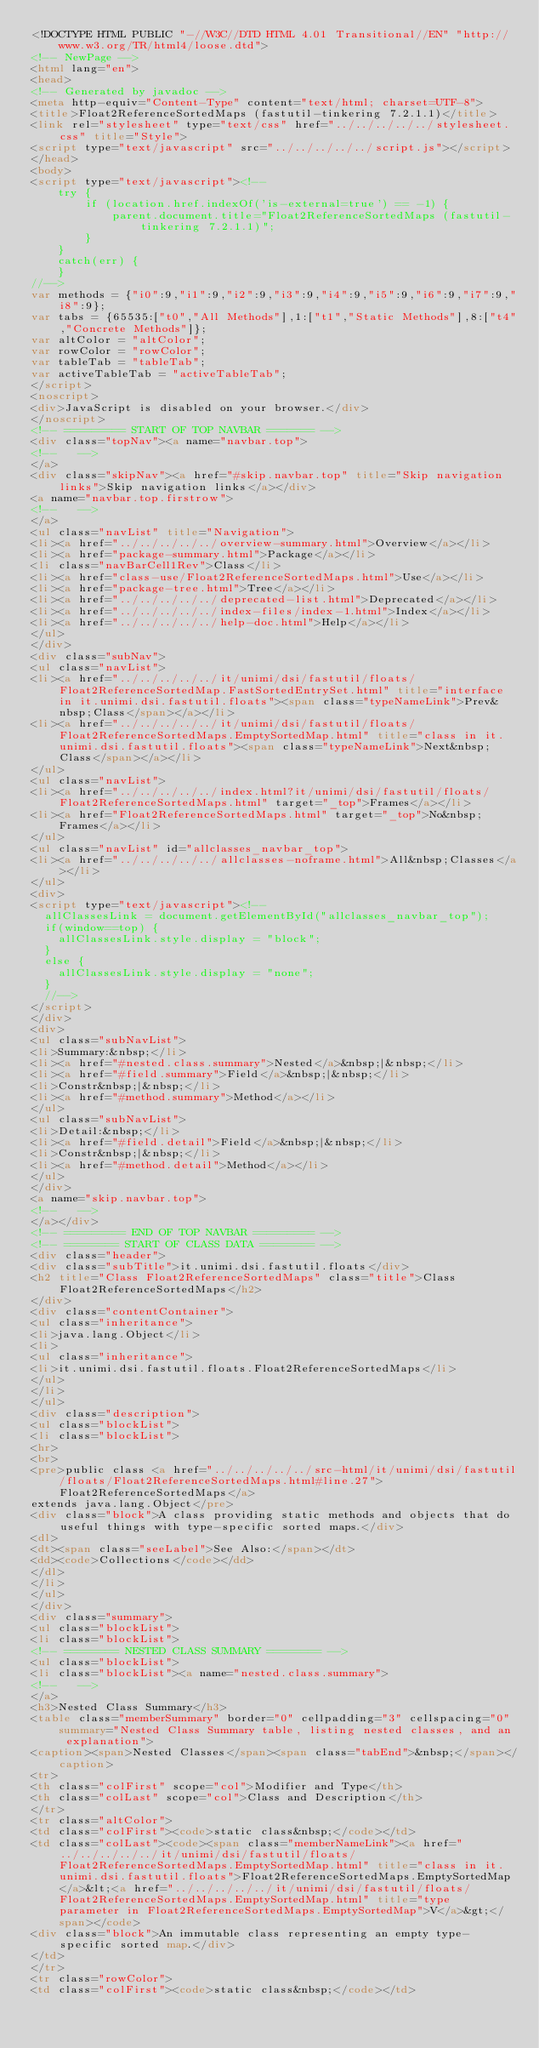Convert code to text. <code><loc_0><loc_0><loc_500><loc_500><_HTML_><!DOCTYPE HTML PUBLIC "-//W3C//DTD HTML 4.01 Transitional//EN" "http://www.w3.org/TR/html4/loose.dtd">
<!-- NewPage -->
<html lang="en">
<head>
<!-- Generated by javadoc -->
<meta http-equiv="Content-Type" content="text/html; charset=UTF-8">
<title>Float2ReferenceSortedMaps (fastutil-tinkering 7.2.1.1)</title>
<link rel="stylesheet" type="text/css" href="../../../../../stylesheet.css" title="Style">
<script type="text/javascript" src="../../../../../script.js"></script>
</head>
<body>
<script type="text/javascript"><!--
    try {
        if (location.href.indexOf('is-external=true') == -1) {
            parent.document.title="Float2ReferenceSortedMaps (fastutil-tinkering 7.2.1.1)";
        }
    }
    catch(err) {
    }
//-->
var methods = {"i0":9,"i1":9,"i2":9,"i3":9,"i4":9,"i5":9,"i6":9,"i7":9,"i8":9};
var tabs = {65535:["t0","All Methods"],1:["t1","Static Methods"],8:["t4","Concrete Methods"]};
var altColor = "altColor";
var rowColor = "rowColor";
var tableTab = "tableTab";
var activeTableTab = "activeTableTab";
</script>
<noscript>
<div>JavaScript is disabled on your browser.</div>
</noscript>
<!-- ========= START OF TOP NAVBAR ======= -->
<div class="topNav"><a name="navbar.top">
<!--   -->
</a>
<div class="skipNav"><a href="#skip.navbar.top" title="Skip navigation links">Skip navigation links</a></div>
<a name="navbar.top.firstrow">
<!--   -->
</a>
<ul class="navList" title="Navigation">
<li><a href="../../../../../overview-summary.html">Overview</a></li>
<li><a href="package-summary.html">Package</a></li>
<li class="navBarCell1Rev">Class</li>
<li><a href="class-use/Float2ReferenceSortedMaps.html">Use</a></li>
<li><a href="package-tree.html">Tree</a></li>
<li><a href="../../../../../deprecated-list.html">Deprecated</a></li>
<li><a href="../../../../../index-files/index-1.html">Index</a></li>
<li><a href="../../../../../help-doc.html">Help</a></li>
</ul>
</div>
<div class="subNav">
<ul class="navList">
<li><a href="../../../../../it/unimi/dsi/fastutil/floats/Float2ReferenceSortedMap.FastSortedEntrySet.html" title="interface in it.unimi.dsi.fastutil.floats"><span class="typeNameLink">Prev&nbsp;Class</span></a></li>
<li><a href="../../../../../it/unimi/dsi/fastutil/floats/Float2ReferenceSortedMaps.EmptySortedMap.html" title="class in it.unimi.dsi.fastutil.floats"><span class="typeNameLink">Next&nbsp;Class</span></a></li>
</ul>
<ul class="navList">
<li><a href="../../../../../index.html?it/unimi/dsi/fastutil/floats/Float2ReferenceSortedMaps.html" target="_top">Frames</a></li>
<li><a href="Float2ReferenceSortedMaps.html" target="_top">No&nbsp;Frames</a></li>
</ul>
<ul class="navList" id="allclasses_navbar_top">
<li><a href="../../../../../allclasses-noframe.html">All&nbsp;Classes</a></li>
</ul>
<div>
<script type="text/javascript"><!--
  allClassesLink = document.getElementById("allclasses_navbar_top");
  if(window==top) {
    allClassesLink.style.display = "block";
  }
  else {
    allClassesLink.style.display = "none";
  }
  //-->
</script>
</div>
<div>
<ul class="subNavList">
<li>Summary:&nbsp;</li>
<li><a href="#nested.class.summary">Nested</a>&nbsp;|&nbsp;</li>
<li><a href="#field.summary">Field</a>&nbsp;|&nbsp;</li>
<li>Constr&nbsp;|&nbsp;</li>
<li><a href="#method.summary">Method</a></li>
</ul>
<ul class="subNavList">
<li>Detail:&nbsp;</li>
<li><a href="#field.detail">Field</a>&nbsp;|&nbsp;</li>
<li>Constr&nbsp;|&nbsp;</li>
<li><a href="#method.detail">Method</a></li>
</ul>
</div>
<a name="skip.navbar.top">
<!--   -->
</a></div>
<!-- ========= END OF TOP NAVBAR ========= -->
<!-- ======== START OF CLASS DATA ======== -->
<div class="header">
<div class="subTitle">it.unimi.dsi.fastutil.floats</div>
<h2 title="Class Float2ReferenceSortedMaps" class="title">Class Float2ReferenceSortedMaps</h2>
</div>
<div class="contentContainer">
<ul class="inheritance">
<li>java.lang.Object</li>
<li>
<ul class="inheritance">
<li>it.unimi.dsi.fastutil.floats.Float2ReferenceSortedMaps</li>
</ul>
</li>
</ul>
<div class="description">
<ul class="blockList">
<li class="blockList">
<hr>
<br>
<pre>public class <a href="../../../../../src-html/it/unimi/dsi/fastutil/floats/Float2ReferenceSortedMaps.html#line.27">Float2ReferenceSortedMaps</a>
extends java.lang.Object</pre>
<div class="block">A class providing static methods and objects that do useful things with type-specific sorted maps.</div>
<dl>
<dt><span class="seeLabel">See Also:</span></dt>
<dd><code>Collections</code></dd>
</dl>
</li>
</ul>
</div>
<div class="summary">
<ul class="blockList">
<li class="blockList">
<!-- ======== NESTED CLASS SUMMARY ======== -->
<ul class="blockList">
<li class="blockList"><a name="nested.class.summary">
<!--   -->
</a>
<h3>Nested Class Summary</h3>
<table class="memberSummary" border="0" cellpadding="3" cellspacing="0" summary="Nested Class Summary table, listing nested classes, and an explanation">
<caption><span>Nested Classes</span><span class="tabEnd">&nbsp;</span></caption>
<tr>
<th class="colFirst" scope="col">Modifier and Type</th>
<th class="colLast" scope="col">Class and Description</th>
</tr>
<tr class="altColor">
<td class="colFirst"><code>static class&nbsp;</code></td>
<td class="colLast"><code><span class="memberNameLink"><a href="../../../../../it/unimi/dsi/fastutil/floats/Float2ReferenceSortedMaps.EmptySortedMap.html" title="class in it.unimi.dsi.fastutil.floats">Float2ReferenceSortedMaps.EmptySortedMap</a>&lt;<a href="../../../../../it/unimi/dsi/fastutil/floats/Float2ReferenceSortedMaps.EmptySortedMap.html" title="type parameter in Float2ReferenceSortedMaps.EmptySortedMap">V</a>&gt;</span></code>
<div class="block">An immutable class representing an empty type-specific sorted map.</div>
</td>
</tr>
<tr class="rowColor">
<td class="colFirst"><code>static class&nbsp;</code></td></code> 